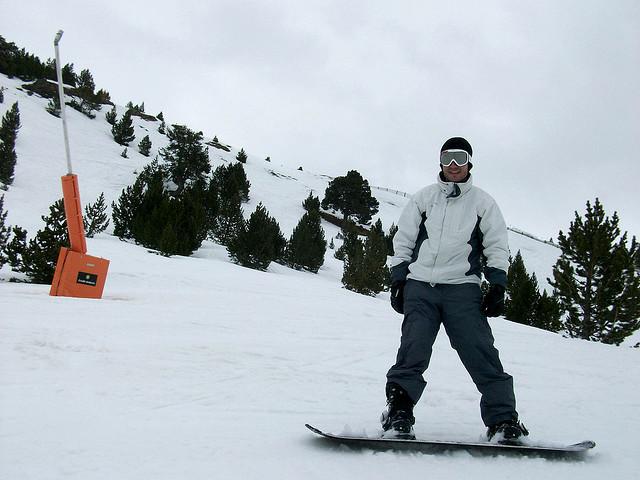Is it cold in the image?
Write a very short answer. Yes. What is the man wearing on his face?
Be succinct. Goggles. What is this man standing on?
Be succinct. Snowboard. 